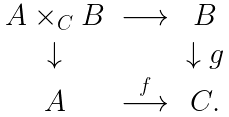<formula> <loc_0><loc_0><loc_500><loc_500>\begin{array} { c c c } A \times _ { C } B & \longrightarrow & B \\ \downarrow & & \downarrow g \\ A & \stackrel { f } \longrightarrow & C . \end{array}</formula> 